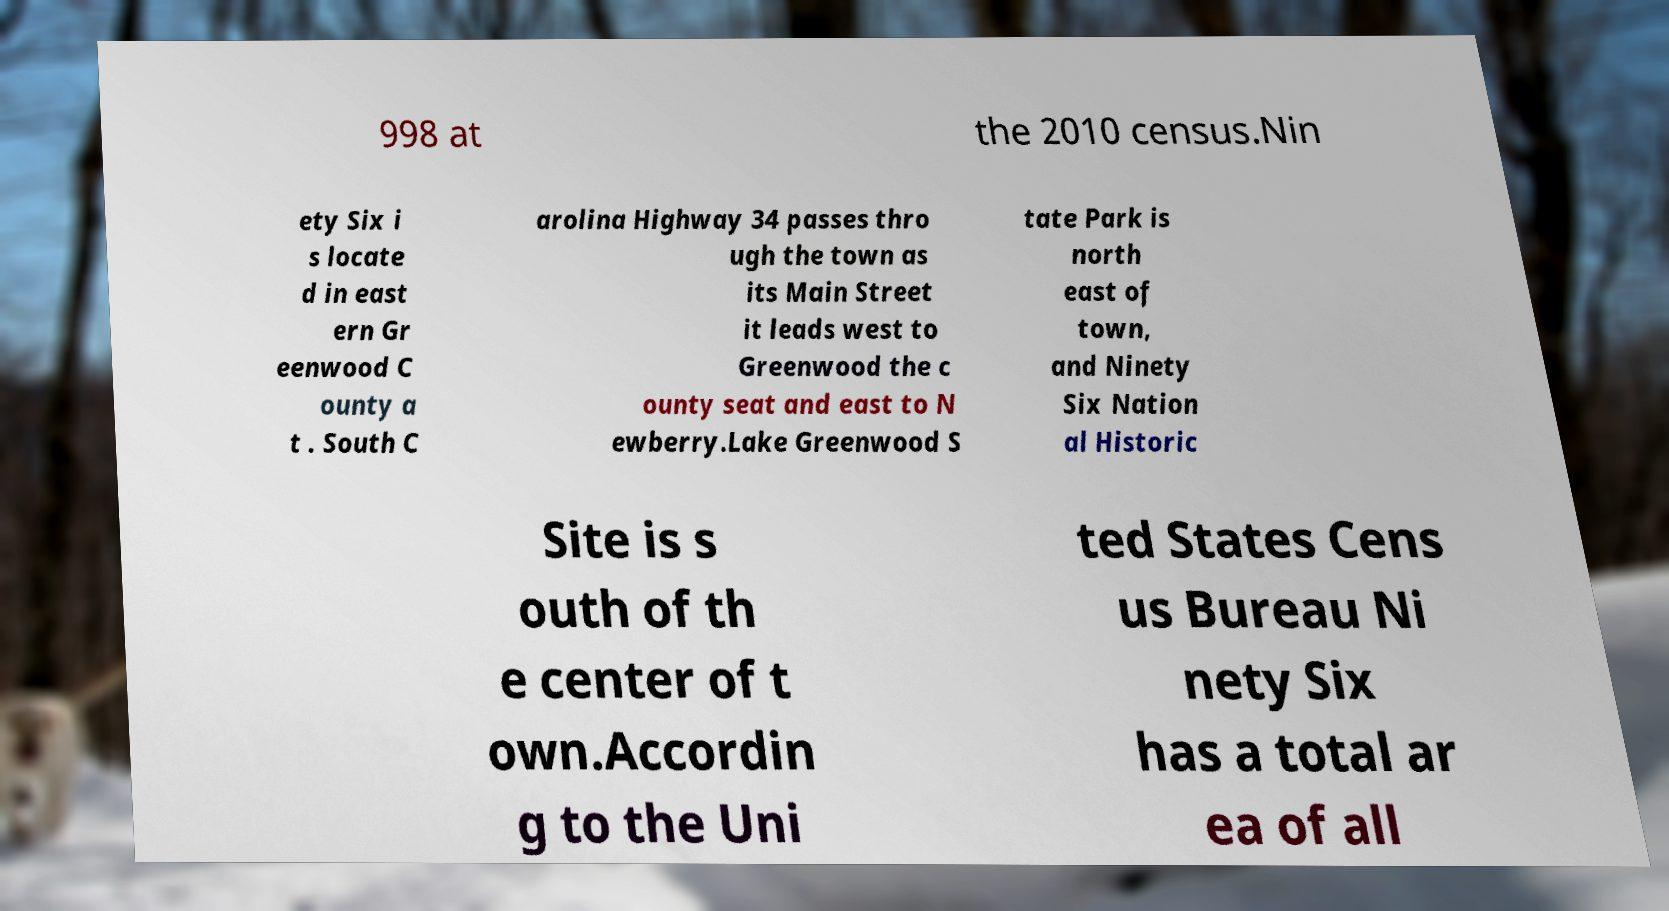Please identify and transcribe the text found in this image. 998 at the 2010 census.Nin ety Six i s locate d in east ern Gr eenwood C ounty a t . South C arolina Highway 34 passes thro ugh the town as its Main Street it leads west to Greenwood the c ounty seat and east to N ewberry.Lake Greenwood S tate Park is north east of town, and Ninety Six Nation al Historic Site is s outh of th e center of t own.Accordin g to the Uni ted States Cens us Bureau Ni nety Six has a total ar ea of all 